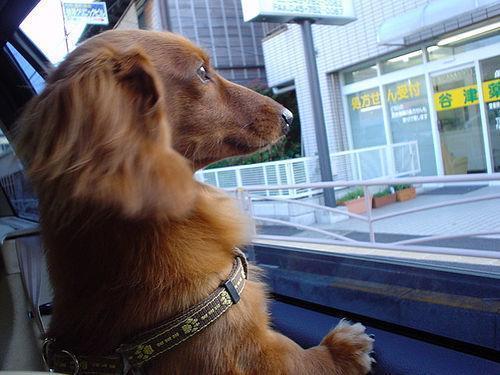How many elephants are shown?
Give a very brief answer. 0. 